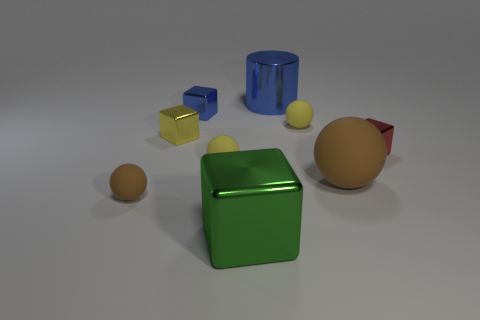Is there a tiny blue metal thing that has the same shape as the big rubber object? While there is a small blue object, it does not share the same shape as any of the larger rubber objects present, which appear to be spherical. The small blue object is rather cube-shaped. 